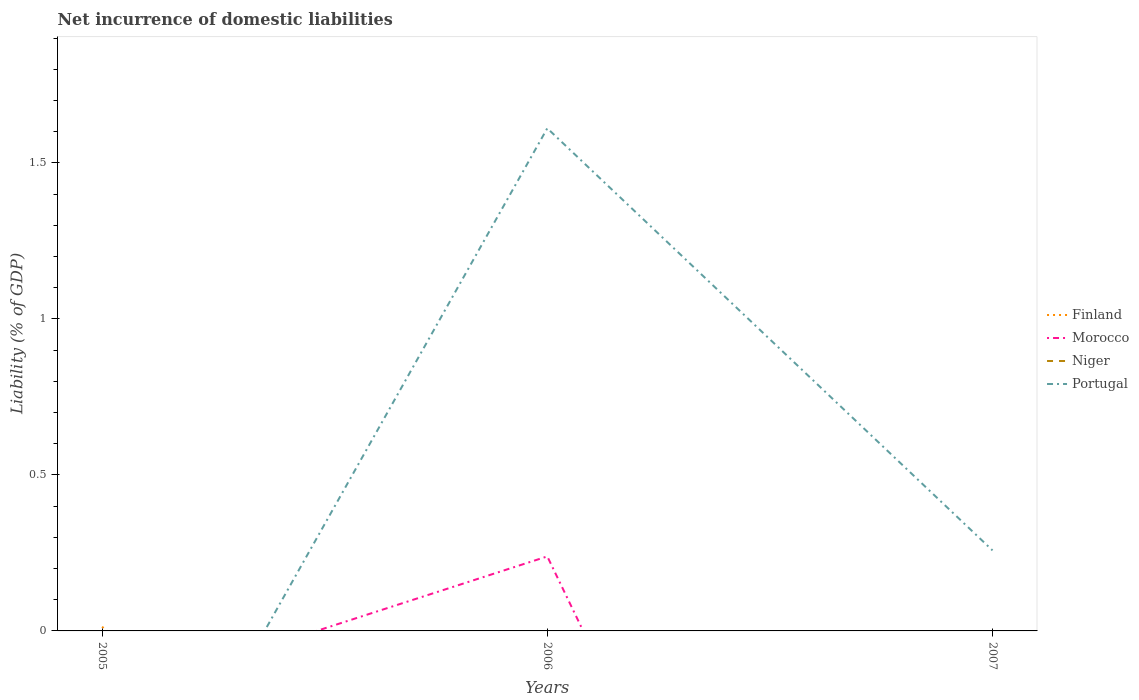How many different coloured lines are there?
Make the answer very short. 3. Does the line corresponding to Portugal intersect with the line corresponding to Niger?
Your answer should be very brief. Yes. Is the number of lines equal to the number of legend labels?
Give a very brief answer. No. Across all years, what is the maximum net incurrence of domestic liabilities in Niger?
Your response must be concise. 0. What is the total net incurrence of domestic liabilities in Portugal in the graph?
Provide a succinct answer. 1.35. What is the difference between the highest and the second highest net incurrence of domestic liabilities in Portugal?
Offer a terse response. 1.61. What is the difference between the highest and the lowest net incurrence of domestic liabilities in Morocco?
Provide a succinct answer. 1. How many lines are there?
Your response must be concise. 3. What is the difference between two consecutive major ticks on the Y-axis?
Your answer should be compact. 0.5. Does the graph contain any zero values?
Provide a short and direct response. Yes. Does the graph contain grids?
Your answer should be very brief. No. Where does the legend appear in the graph?
Keep it short and to the point. Center right. How many legend labels are there?
Provide a succinct answer. 4. How are the legend labels stacked?
Give a very brief answer. Vertical. What is the title of the graph?
Provide a short and direct response. Net incurrence of domestic liabilities. Does "Latin America(developing only)" appear as one of the legend labels in the graph?
Ensure brevity in your answer.  No. What is the label or title of the X-axis?
Keep it short and to the point. Years. What is the label or title of the Y-axis?
Offer a terse response. Liability (% of GDP). What is the Liability (% of GDP) in Finland in 2005?
Your response must be concise. 0.01. What is the Liability (% of GDP) of Niger in 2005?
Offer a very short reply. 0. What is the Liability (% of GDP) of Portugal in 2005?
Offer a terse response. 0. What is the Liability (% of GDP) in Finland in 2006?
Provide a succinct answer. 0. What is the Liability (% of GDP) in Morocco in 2006?
Your response must be concise. 0.24. What is the Liability (% of GDP) of Niger in 2006?
Provide a short and direct response. 0. What is the Liability (% of GDP) in Portugal in 2006?
Ensure brevity in your answer.  1.61. What is the Liability (% of GDP) of Finland in 2007?
Your response must be concise. 0. What is the Liability (% of GDP) of Portugal in 2007?
Your answer should be very brief. 0.26. Across all years, what is the maximum Liability (% of GDP) in Finland?
Keep it short and to the point. 0.01. Across all years, what is the maximum Liability (% of GDP) in Morocco?
Your response must be concise. 0.24. Across all years, what is the maximum Liability (% of GDP) in Portugal?
Offer a terse response. 1.61. Across all years, what is the minimum Liability (% of GDP) of Morocco?
Your answer should be very brief. 0. Across all years, what is the minimum Liability (% of GDP) in Portugal?
Offer a very short reply. 0. What is the total Liability (% of GDP) in Finland in the graph?
Make the answer very short. 0.01. What is the total Liability (% of GDP) in Morocco in the graph?
Offer a terse response. 0.24. What is the total Liability (% of GDP) in Portugal in the graph?
Provide a succinct answer. 1.87. What is the difference between the Liability (% of GDP) of Portugal in 2006 and that in 2007?
Your answer should be very brief. 1.35. What is the difference between the Liability (% of GDP) in Finland in 2005 and the Liability (% of GDP) in Morocco in 2006?
Ensure brevity in your answer.  -0.23. What is the difference between the Liability (% of GDP) in Finland in 2005 and the Liability (% of GDP) in Portugal in 2006?
Provide a succinct answer. -1.6. What is the difference between the Liability (% of GDP) in Finland in 2005 and the Liability (% of GDP) in Portugal in 2007?
Provide a short and direct response. -0.24. What is the difference between the Liability (% of GDP) of Morocco in 2006 and the Liability (% of GDP) of Portugal in 2007?
Ensure brevity in your answer.  -0.02. What is the average Liability (% of GDP) in Finland per year?
Provide a short and direct response. 0. What is the average Liability (% of GDP) in Morocco per year?
Ensure brevity in your answer.  0.08. What is the average Liability (% of GDP) in Niger per year?
Your response must be concise. 0. What is the average Liability (% of GDP) in Portugal per year?
Provide a short and direct response. 0.62. In the year 2006, what is the difference between the Liability (% of GDP) in Morocco and Liability (% of GDP) in Portugal?
Ensure brevity in your answer.  -1.37. What is the ratio of the Liability (% of GDP) in Portugal in 2006 to that in 2007?
Ensure brevity in your answer.  6.24. What is the difference between the highest and the lowest Liability (% of GDP) of Finland?
Provide a succinct answer. 0.01. What is the difference between the highest and the lowest Liability (% of GDP) of Morocco?
Your answer should be very brief. 0.24. What is the difference between the highest and the lowest Liability (% of GDP) of Portugal?
Your response must be concise. 1.61. 